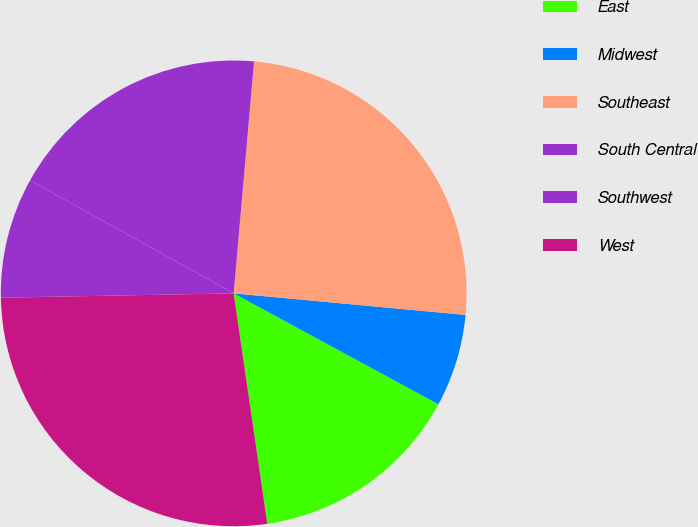<chart> <loc_0><loc_0><loc_500><loc_500><pie_chart><fcel>East<fcel>Midwest<fcel>Southeast<fcel>South Central<fcel>Southwest<fcel>West<nl><fcel>14.79%<fcel>6.43%<fcel>25.08%<fcel>18.33%<fcel>8.36%<fcel>27.01%<nl></chart> 